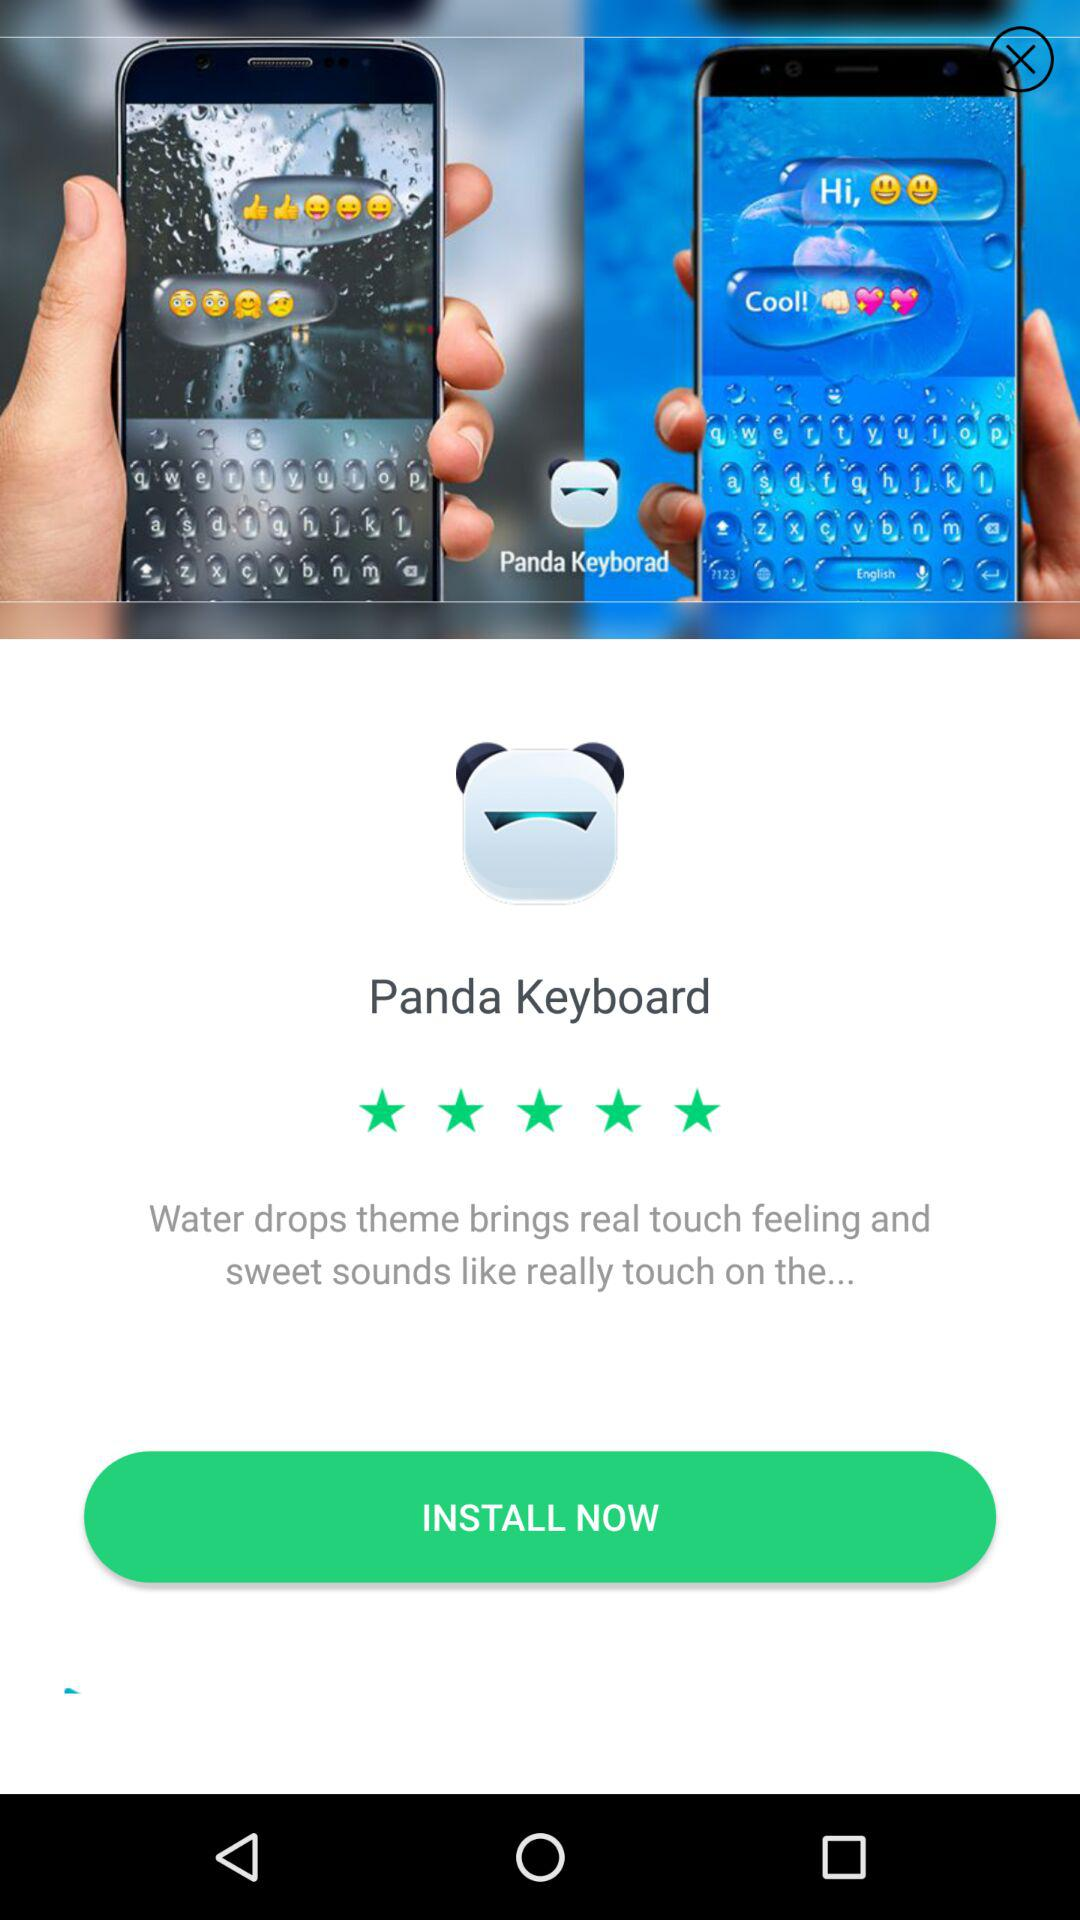How many stars are there for the application? There are 5 stars for the application. 